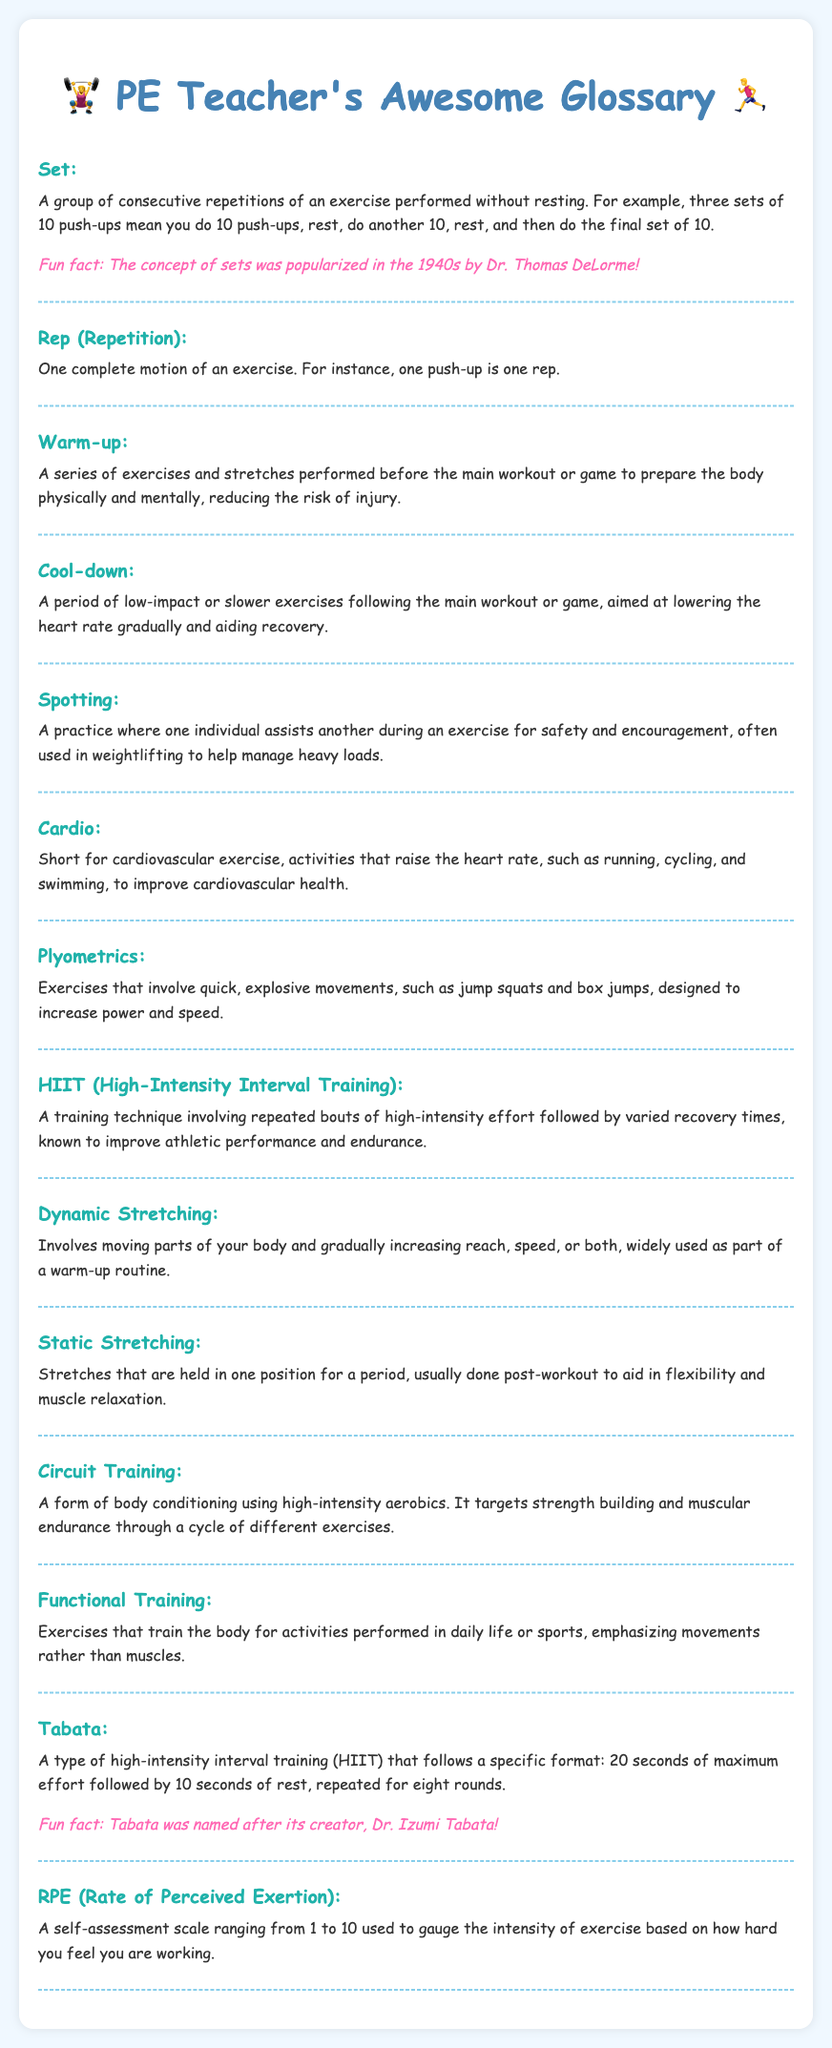What is the definition of a Set? The definition is a group of consecutive repetitions of an exercise performed without resting.
Answer: A group of consecutive repetitions of an exercise performed without resting What does Rep stand for? Rep stands for Repetition, which is one complete motion of an exercise.
Answer: Repetition What is the purpose of a Warm-up? The purpose is to prepare the body physically and mentally, reducing the risk of injury before the main workout or game.
Answer: To prepare the body physically and mentally What is Spotting in physical education? Spotting is assisting another during an exercise for safety and encouragement.
Answer: Assisting another for safety and encouragement How long is a Tabata round? A Tabata round consists of 20 seconds of maximum effort followed by 10 seconds of rest.
Answer: 20 seconds What type of exercises are involved in HIIT? HIIT involves repeated bouts of high-intensity effort followed by varied recovery times.
Answer: High-intensity effort followed by varied recovery times What is the fun fact about the term Tabata? The fun fact is that Tabata was named after its creator, Dr. Izumi Tabata.
Answer: It was named after Dr. Izumi Tabata What does RPE stand for? RPE stands for Rate of Perceived Exertion.
Answer: Rate of Perceived Exertion 